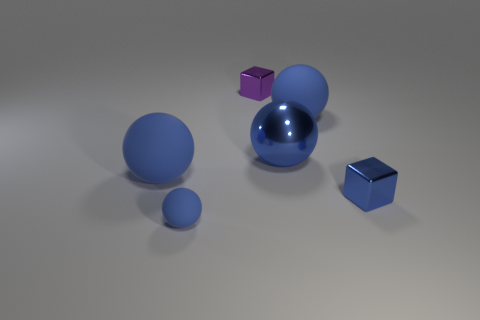What shape is the matte object that is the same size as the purple metal block?
Provide a succinct answer. Sphere. There is a shiny block that is behind the big blue thing that is to the left of the tiny blue matte object; is there a big blue thing that is behind it?
Provide a succinct answer. No. Are there any cyan matte cylinders of the same size as the purple metallic object?
Provide a short and direct response. No. What is the size of the blue object in front of the small blue metal object?
Ensure brevity in your answer.  Small. There is a block that is in front of the small shiny cube behind the blue rubber thing that is on the left side of the small matte sphere; what color is it?
Keep it short and to the point. Blue. What is the color of the big shiny sphere behind the tiny blue object to the left of the small blue metallic thing?
Make the answer very short. Blue. Are there more objects that are on the right side of the large metal object than tiny blue rubber things behind the tiny purple block?
Offer a very short reply. Yes. Is the material of the large object that is left of the purple object the same as the large blue object behind the blue metallic sphere?
Offer a very short reply. Yes. There is a big blue shiny ball; are there any big things in front of it?
Provide a succinct answer. Yes. What number of blue things are large rubber spheres or tiny matte objects?
Make the answer very short. 3. 